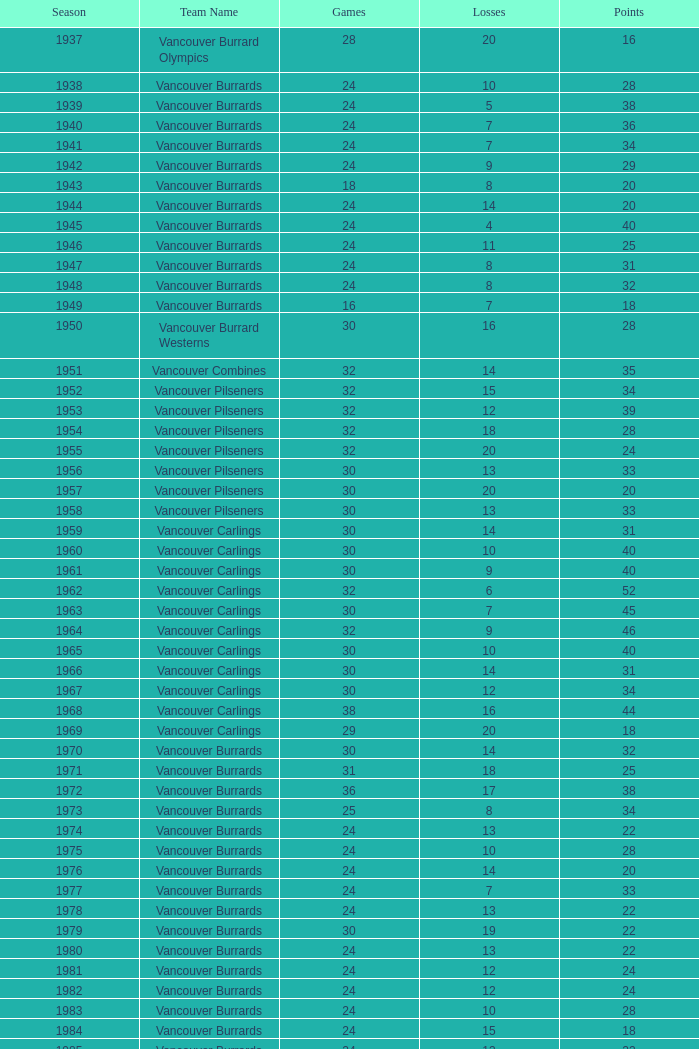What's the lowest number of points with fewer than 8 losses and fewer than 24 games for the vancouver burrards? 18.0. 